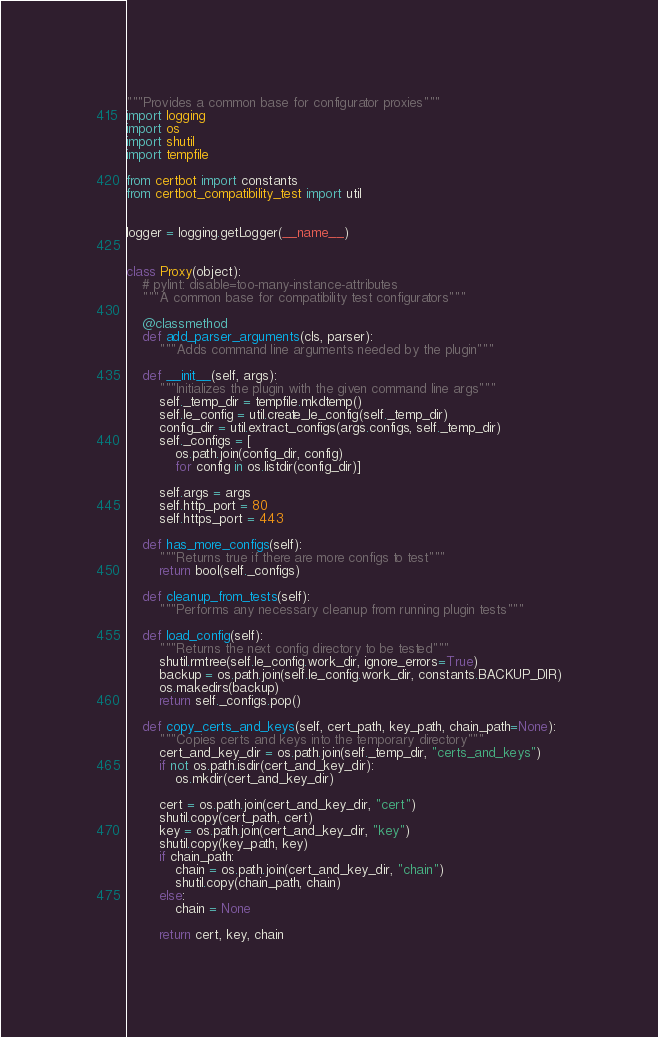Convert code to text. <code><loc_0><loc_0><loc_500><loc_500><_Python_>"""Provides a common base for configurator proxies"""
import logging
import os
import shutil
import tempfile

from certbot import constants
from certbot_compatibility_test import util


logger = logging.getLogger(__name__)


class Proxy(object):
    # pylint: disable=too-many-instance-attributes
    """A common base for compatibility test configurators"""

    @classmethod
    def add_parser_arguments(cls, parser):
        """Adds command line arguments needed by the plugin"""

    def __init__(self, args):
        """Initializes the plugin with the given command line args"""
        self._temp_dir = tempfile.mkdtemp()
        self.le_config = util.create_le_config(self._temp_dir)
        config_dir = util.extract_configs(args.configs, self._temp_dir)
        self._configs = [
            os.path.join(config_dir, config)
            for config in os.listdir(config_dir)]

        self.args = args
        self.http_port = 80
        self.https_port = 443

    def has_more_configs(self):
        """Returns true if there are more configs to test"""
        return bool(self._configs)

    def cleanup_from_tests(self):
        """Performs any necessary cleanup from running plugin tests"""

    def load_config(self):
        """Returns the next config directory to be tested"""
        shutil.rmtree(self.le_config.work_dir, ignore_errors=True)
        backup = os.path.join(self.le_config.work_dir, constants.BACKUP_DIR)
        os.makedirs(backup)
        return self._configs.pop()

    def copy_certs_and_keys(self, cert_path, key_path, chain_path=None):
        """Copies certs and keys into the temporary directory"""
        cert_and_key_dir = os.path.join(self._temp_dir, "certs_and_keys")
        if not os.path.isdir(cert_and_key_dir):
            os.mkdir(cert_and_key_dir)

        cert = os.path.join(cert_and_key_dir, "cert")
        shutil.copy(cert_path, cert)
        key = os.path.join(cert_and_key_dir, "key")
        shutil.copy(key_path, key)
        if chain_path:
            chain = os.path.join(cert_and_key_dir, "chain")
            shutil.copy(chain_path, chain)
        else:
            chain = None

        return cert, key, chain
</code> 